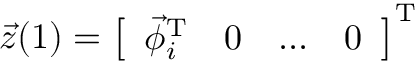Convert formula to latex. <formula><loc_0><loc_0><loc_500><loc_500>\vec { z } ( 1 ) = \left [ \begin{array} { l l l l } { \vec { \phi } _ { i } ^ { T } } & { 0 } & { \dots } & { 0 } \end{array} \right ] ^ { T }</formula> 